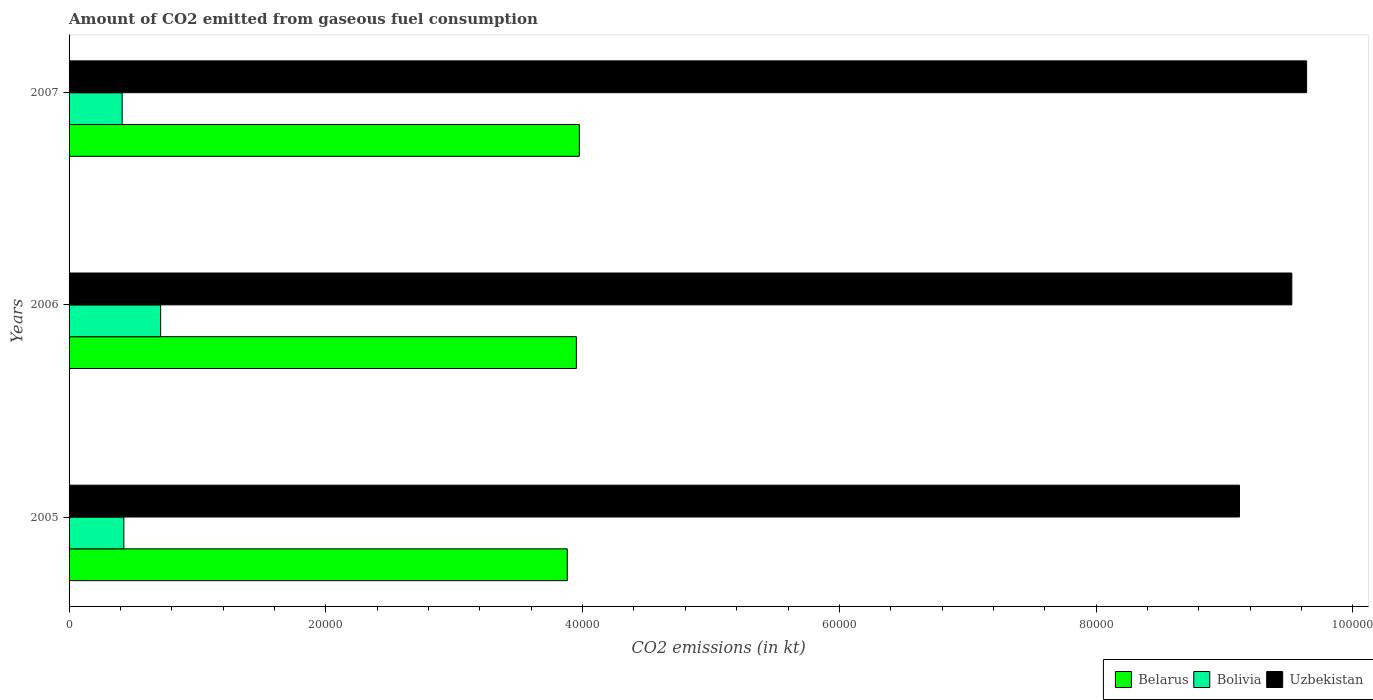Are the number of bars per tick equal to the number of legend labels?
Your answer should be compact. Yes. How many bars are there on the 3rd tick from the bottom?
Keep it short and to the point. 3. In how many cases, is the number of bars for a given year not equal to the number of legend labels?
Keep it short and to the point. 0. What is the amount of CO2 emitted in Uzbekistan in 2006?
Offer a very short reply. 9.52e+04. Across all years, what is the maximum amount of CO2 emitted in Belarus?
Make the answer very short. 3.97e+04. Across all years, what is the minimum amount of CO2 emitted in Bolivia?
Provide a succinct answer. 4136.38. In which year was the amount of CO2 emitted in Belarus maximum?
Your response must be concise. 2007. What is the total amount of CO2 emitted in Belarus in the graph?
Offer a very short reply. 1.18e+05. What is the difference between the amount of CO2 emitted in Bolivia in 2005 and that in 2006?
Keep it short and to the point. -2863.93. What is the difference between the amount of CO2 emitted in Bolivia in 2006 and the amount of CO2 emitted in Belarus in 2005?
Provide a succinct answer. -3.17e+04. What is the average amount of CO2 emitted in Uzbekistan per year?
Offer a very short reply. 9.43e+04. In the year 2007, what is the difference between the amount of CO2 emitted in Bolivia and amount of CO2 emitted in Belarus?
Your answer should be compact. -3.56e+04. What is the ratio of the amount of CO2 emitted in Belarus in 2005 to that in 2007?
Provide a succinct answer. 0.98. Is the amount of CO2 emitted in Bolivia in 2005 less than that in 2007?
Your response must be concise. No. Is the difference between the amount of CO2 emitted in Bolivia in 2006 and 2007 greater than the difference between the amount of CO2 emitted in Belarus in 2006 and 2007?
Give a very brief answer. Yes. What is the difference between the highest and the second highest amount of CO2 emitted in Uzbekistan?
Ensure brevity in your answer.  1151.44. What is the difference between the highest and the lowest amount of CO2 emitted in Uzbekistan?
Your answer should be compact. 5229.14. In how many years, is the amount of CO2 emitted in Uzbekistan greater than the average amount of CO2 emitted in Uzbekistan taken over all years?
Provide a short and direct response. 2. Is the sum of the amount of CO2 emitted in Bolivia in 2005 and 2006 greater than the maximum amount of CO2 emitted in Belarus across all years?
Ensure brevity in your answer.  No. What does the 3rd bar from the top in 2006 represents?
Give a very brief answer. Belarus. What does the 3rd bar from the bottom in 2005 represents?
Ensure brevity in your answer.  Uzbekistan. Is it the case that in every year, the sum of the amount of CO2 emitted in Uzbekistan and amount of CO2 emitted in Bolivia is greater than the amount of CO2 emitted in Belarus?
Your answer should be very brief. Yes. How many bars are there?
Provide a succinct answer. 9. How many years are there in the graph?
Keep it short and to the point. 3. What is the difference between two consecutive major ticks on the X-axis?
Give a very brief answer. 2.00e+04. Does the graph contain grids?
Your answer should be compact. No. Where does the legend appear in the graph?
Keep it short and to the point. Bottom right. How are the legend labels stacked?
Provide a succinct answer. Horizontal. What is the title of the graph?
Your answer should be compact. Amount of CO2 emitted from gaseous fuel consumption. Does "Belgium" appear as one of the legend labels in the graph?
Your answer should be very brief. No. What is the label or title of the X-axis?
Your answer should be very brief. CO2 emissions (in kt). What is the CO2 emissions (in kt) of Belarus in 2005?
Provide a succinct answer. 3.88e+04. What is the CO2 emissions (in kt) in Bolivia in 2005?
Your response must be concise. 4268.39. What is the CO2 emissions (in kt) of Uzbekistan in 2005?
Your answer should be very brief. 9.12e+04. What is the CO2 emissions (in kt) in Belarus in 2006?
Your answer should be very brief. 3.95e+04. What is the CO2 emissions (in kt) of Bolivia in 2006?
Keep it short and to the point. 7132.31. What is the CO2 emissions (in kt) of Uzbekistan in 2006?
Your answer should be compact. 9.52e+04. What is the CO2 emissions (in kt) in Belarus in 2007?
Keep it short and to the point. 3.97e+04. What is the CO2 emissions (in kt) of Bolivia in 2007?
Your answer should be very brief. 4136.38. What is the CO2 emissions (in kt) of Uzbekistan in 2007?
Make the answer very short. 9.64e+04. Across all years, what is the maximum CO2 emissions (in kt) of Belarus?
Your answer should be compact. 3.97e+04. Across all years, what is the maximum CO2 emissions (in kt) of Bolivia?
Ensure brevity in your answer.  7132.31. Across all years, what is the maximum CO2 emissions (in kt) of Uzbekistan?
Make the answer very short. 9.64e+04. Across all years, what is the minimum CO2 emissions (in kt) of Belarus?
Provide a succinct answer. 3.88e+04. Across all years, what is the minimum CO2 emissions (in kt) in Bolivia?
Give a very brief answer. 4136.38. Across all years, what is the minimum CO2 emissions (in kt) in Uzbekistan?
Your answer should be very brief. 9.12e+04. What is the total CO2 emissions (in kt) of Belarus in the graph?
Make the answer very short. 1.18e+05. What is the total CO2 emissions (in kt) of Bolivia in the graph?
Offer a terse response. 1.55e+04. What is the total CO2 emissions (in kt) in Uzbekistan in the graph?
Your answer should be very brief. 2.83e+05. What is the difference between the CO2 emissions (in kt) in Belarus in 2005 and that in 2006?
Ensure brevity in your answer.  -707.73. What is the difference between the CO2 emissions (in kt) of Bolivia in 2005 and that in 2006?
Provide a succinct answer. -2863.93. What is the difference between the CO2 emissions (in kt) in Uzbekistan in 2005 and that in 2006?
Ensure brevity in your answer.  -4077.7. What is the difference between the CO2 emissions (in kt) of Belarus in 2005 and that in 2007?
Give a very brief answer. -938.75. What is the difference between the CO2 emissions (in kt) in Bolivia in 2005 and that in 2007?
Offer a terse response. 132.01. What is the difference between the CO2 emissions (in kt) of Uzbekistan in 2005 and that in 2007?
Offer a terse response. -5229.14. What is the difference between the CO2 emissions (in kt) in Belarus in 2006 and that in 2007?
Provide a succinct answer. -231.02. What is the difference between the CO2 emissions (in kt) of Bolivia in 2006 and that in 2007?
Your response must be concise. 2995.94. What is the difference between the CO2 emissions (in kt) of Uzbekistan in 2006 and that in 2007?
Your answer should be compact. -1151.44. What is the difference between the CO2 emissions (in kt) in Belarus in 2005 and the CO2 emissions (in kt) in Bolivia in 2006?
Provide a succinct answer. 3.17e+04. What is the difference between the CO2 emissions (in kt) in Belarus in 2005 and the CO2 emissions (in kt) in Uzbekistan in 2006?
Provide a short and direct response. -5.64e+04. What is the difference between the CO2 emissions (in kt) in Bolivia in 2005 and the CO2 emissions (in kt) in Uzbekistan in 2006?
Offer a very short reply. -9.10e+04. What is the difference between the CO2 emissions (in kt) in Belarus in 2005 and the CO2 emissions (in kt) in Bolivia in 2007?
Offer a terse response. 3.47e+04. What is the difference between the CO2 emissions (in kt) in Belarus in 2005 and the CO2 emissions (in kt) in Uzbekistan in 2007?
Offer a terse response. -5.76e+04. What is the difference between the CO2 emissions (in kt) of Bolivia in 2005 and the CO2 emissions (in kt) of Uzbekistan in 2007?
Your answer should be very brief. -9.21e+04. What is the difference between the CO2 emissions (in kt) of Belarus in 2006 and the CO2 emissions (in kt) of Bolivia in 2007?
Provide a succinct answer. 3.54e+04. What is the difference between the CO2 emissions (in kt) of Belarus in 2006 and the CO2 emissions (in kt) of Uzbekistan in 2007?
Provide a succinct answer. -5.69e+04. What is the difference between the CO2 emissions (in kt) of Bolivia in 2006 and the CO2 emissions (in kt) of Uzbekistan in 2007?
Your answer should be very brief. -8.93e+04. What is the average CO2 emissions (in kt) in Belarus per year?
Your response must be concise. 3.94e+04. What is the average CO2 emissions (in kt) of Bolivia per year?
Provide a short and direct response. 5179.03. What is the average CO2 emissions (in kt) of Uzbekistan per year?
Give a very brief answer. 9.43e+04. In the year 2005, what is the difference between the CO2 emissions (in kt) in Belarus and CO2 emissions (in kt) in Bolivia?
Offer a very short reply. 3.45e+04. In the year 2005, what is the difference between the CO2 emissions (in kt) of Belarus and CO2 emissions (in kt) of Uzbekistan?
Make the answer very short. -5.24e+04. In the year 2005, what is the difference between the CO2 emissions (in kt) of Bolivia and CO2 emissions (in kt) of Uzbekistan?
Provide a succinct answer. -8.69e+04. In the year 2006, what is the difference between the CO2 emissions (in kt) of Belarus and CO2 emissions (in kt) of Bolivia?
Your answer should be compact. 3.24e+04. In the year 2006, what is the difference between the CO2 emissions (in kt) of Belarus and CO2 emissions (in kt) of Uzbekistan?
Make the answer very short. -5.57e+04. In the year 2006, what is the difference between the CO2 emissions (in kt) of Bolivia and CO2 emissions (in kt) of Uzbekistan?
Ensure brevity in your answer.  -8.81e+04. In the year 2007, what is the difference between the CO2 emissions (in kt) in Belarus and CO2 emissions (in kt) in Bolivia?
Your answer should be very brief. 3.56e+04. In the year 2007, what is the difference between the CO2 emissions (in kt) of Belarus and CO2 emissions (in kt) of Uzbekistan?
Make the answer very short. -5.66e+04. In the year 2007, what is the difference between the CO2 emissions (in kt) of Bolivia and CO2 emissions (in kt) of Uzbekistan?
Your answer should be compact. -9.23e+04. What is the ratio of the CO2 emissions (in kt) in Belarus in 2005 to that in 2006?
Ensure brevity in your answer.  0.98. What is the ratio of the CO2 emissions (in kt) of Bolivia in 2005 to that in 2006?
Your answer should be very brief. 0.6. What is the ratio of the CO2 emissions (in kt) of Uzbekistan in 2005 to that in 2006?
Your response must be concise. 0.96. What is the ratio of the CO2 emissions (in kt) of Belarus in 2005 to that in 2007?
Ensure brevity in your answer.  0.98. What is the ratio of the CO2 emissions (in kt) in Bolivia in 2005 to that in 2007?
Offer a very short reply. 1.03. What is the ratio of the CO2 emissions (in kt) in Uzbekistan in 2005 to that in 2007?
Give a very brief answer. 0.95. What is the ratio of the CO2 emissions (in kt) in Belarus in 2006 to that in 2007?
Ensure brevity in your answer.  0.99. What is the ratio of the CO2 emissions (in kt) in Bolivia in 2006 to that in 2007?
Keep it short and to the point. 1.72. What is the difference between the highest and the second highest CO2 emissions (in kt) of Belarus?
Provide a succinct answer. 231.02. What is the difference between the highest and the second highest CO2 emissions (in kt) of Bolivia?
Ensure brevity in your answer.  2863.93. What is the difference between the highest and the second highest CO2 emissions (in kt) of Uzbekistan?
Your answer should be compact. 1151.44. What is the difference between the highest and the lowest CO2 emissions (in kt) in Belarus?
Offer a terse response. 938.75. What is the difference between the highest and the lowest CO2 emissions (in kt) in Bolivia?
Provide a short and direct response. 2995.94. What is the difference between the highest and the lowest CO2 emissions (in kt) of Uzbekistan?
Keep it short and to the point. 5229.14. 